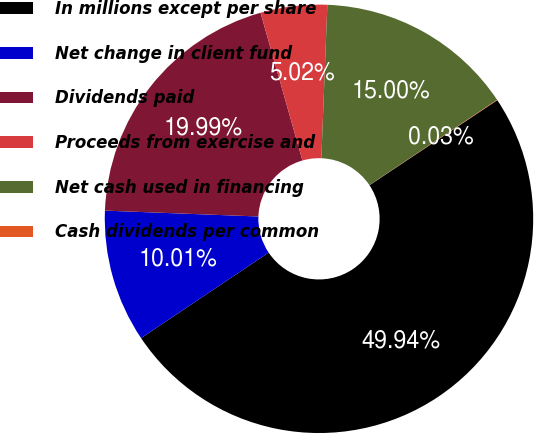<chart> <loc_0><loc_0><loc_500><loc_500><pie_chart><fcel>In millions except per share<fcel>Net change in client fund<fcel>Dividends paid<fcel>Proceeds from exercise and<fcel>Net cash used in financing<fcel>Cash dividends per common<nl><fcel>49.94%<fcel>10.01%<fcel>19.99%<fcel>5.02%<fcel>15.0%<fcel>0.03%<nl></chart> 